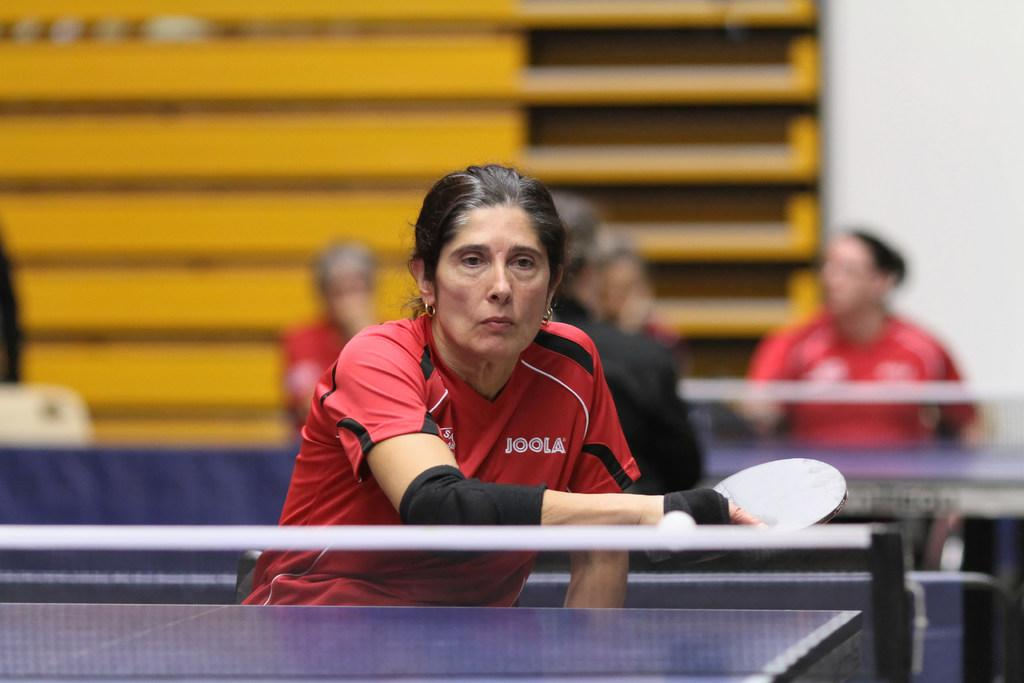What is the woman in the image doing? The woman is playing table tennis. Can you describe the activity the woman is engaged in? The woman is playing a game that involves hitting a small ball back and forth across a table using paddles. Are there any other people present in the image? Yes, there are a few people visible in the background of the image. What type of animal can be seen in the zoo in the image? There is no zoo or animal present in the image; it features a woman playing table tennis. What type of knife is the woman using to play table tennis in the image? The woman is not using a knife to play table tennis; she is using a table tennis paddle. 